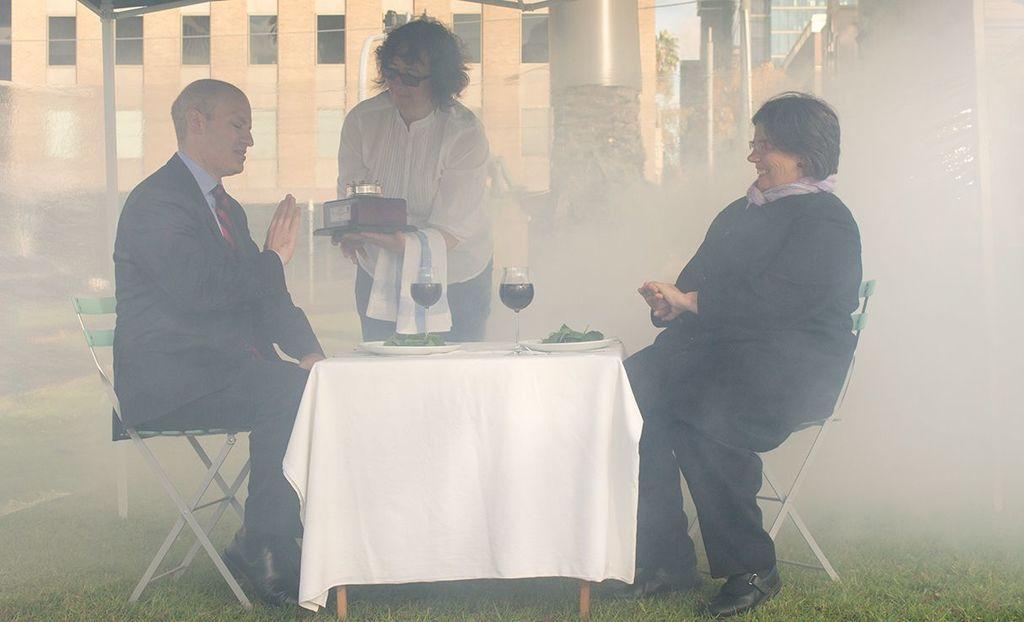Can you describe this image briefly? In this image I can see three people. Among them two people are sitting in front of the table. On the table there are plates and the glasses. At the back there is a building. 